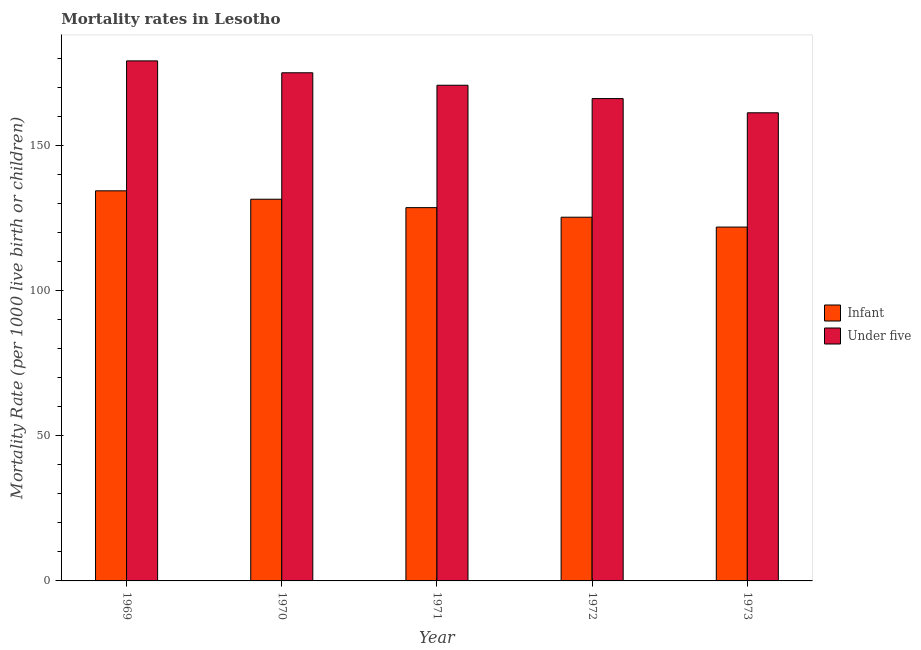Are the number of bars per tick equal to the number of legend labels?
Your answer should be compact. Yes. Are the number of bars on each tick of the X-axis equal?
Offer a terse response. Yes. How many bars are there on the 4th tick from the right?
Keep it short and to the point. 2. In how many cases, is the number of bars for a given year not equal to the number of legend labels?
Provide a short and direct response. 0. What is the infant mortality rate in 1970?
Offer a terse response. 131.6. Across all years, what is the maximum infant mortality rate?
Give a very brief answer. 134.5. Across all years, what is the minimum under-5 mortality rate?
Your response must be concise. 161.4. In which year was the infant mortality rate maximum?
Make the answer very short. 1969. What is the total infant mortality rate in the graph?
Your answer should be very brief. 642.2. What is the difference between the under-5 mortality rate in 1972 and the infant mortality rate in 1973?
Your response must be concise. 4.9. What is the average infant mortality rate per year?
Ensure brevity in your answer.  128.44. In the year 1973, what is the difference between the under-5 mortality rate and infant mortality rate?
Keep it short and to the point. 0. What is the ratio of the under-5 mortality rate in 1969 to that in 1972?
Your answer should be compact. 1.08. Is the under-5 mortality rate in 1971 less than that in 1972?
Your answer should be very brief. No. What is the difference between the highest and the second highest infant mortality rate?
Provide a succinct answer. 2.9. What is the difference between the highest and the lowest infant mortality rate?
Provide a short and direct response. 12.5. In how many years, is the infant mortality rate greater than the average infant mortality rate taken over all years?
Provide a succinct answer. 3. What does the 1st bar from the left in 1972 represents?
Ensure brevity in your answer.  Infant. What does the 2nd bar from the right in 1969 represents?
Offer a terse response. Infant. Are all the bars in the graph horizontal?
Your answer should be compact. No. How many years are there in the graph?
Ensure brevity in your answer.  5. What is the difference between two consecutive major ticks on the Y-axis?
Keep it short and to the point. 50. Does the graph contain grids?
Ensure brevity in your answer.  No. How many legend labels are there?
Make the answer very short. 2. How are the legend labels stacked?
Keep it short and to the point. Vertical. What is the title of the graph?
Offer a very short reply. Mortality rates in Lesotho. What is the label or title of the X-axis?
Offer a terse response. Year. What is the label or title of the Y-axis?
Provide a short and direct response. Mortality Rate (per 1000 live birth or children). What is the Mortality Rate (per 1000 live birth or children) in Infant in 1969?
Your answer should be compact. 134.5. What is the Mortality Rate (per 1000 live birth or children) of Under five in 1969?
Provide a short and direct response. 179.3. What is the Mortality Rate (per 1000 live birth or children) of Infant in 1970?
Provide a succinct answer. 131.6. What is the Mortality Rate (per 1000 live birth or children) of Under five in 1970?
Your answer should be very brief. 175.2. What is the Mortality Rate (per 1000 live birth or children) of Infant in 1971?
Your answer should be compact. 128.7. What is the Mortality Rate (per 1000 live birth or children) of Under five in 1971?
Your answer should be very brief. 170.9. What is the Mortality Rate (per 1000 live birth or children) in Infant in 1972?
Keep it short and to the point. 125.4. What is the Mortality Rate (per 1000 live birth or children) of Under five in 1972?
Make the answer very short. 166.3. What is the Mortality Rate (per 1000 live birth or children) of Infant in 1973?
Give a very brief answer. 122. What is the Mortality Rate (per 1000 live birth or children) of Under five in 1973?
Offer a terse response. 161.4. Across all years, what is the maximum Mortality Rate (per 1000 live birth or children) of Infant?
Your response must be concise. 134.5. Across all years, what is the maximum Mortality Rate (per 1000 live birth or children) of Under five?
Your answer should be compact. 179.3. Across all years, what is the minimum Mortality Rate (per 1000 live birth or children) in Infant?
Ensure brevity in your answer.  122. Across all years, what is the minimum Mortality Rate (per 1000 live birth or children) in Under five?
Your answer should be compact. 161.4. What is the total Mortality Rate (per 1000 live birth or children) in Infant in the graph?
Offer a very short reply. 642.2. What is the total Mortality Rate (per 1000 live birth or children) of Under five in the graph?
Provide a succinct answer. 853.1. What is the difference between the Mortality Rate (per 1000 live birth or children) in Infant in 1969 and that in 1970?
Ensure brevity in your answer.  2.9. What is the difference between the Mortality Rate (per 1000 live birth or children) in Under five in 1969 and that in 1971?
Give a very brief answer. 8.4. What is the difference between the Mortality Rate (per 1000 live birth or children) of Infant in 1969 and that in 1973?
Make the answer very short. 12.5. What is the difference between the Mortality Rate (per 1000 live birth or children) of Infant in 1970 and that in 1971?
Provide a succinct answer. 2.9. What is the difference between the Mortality Rate (per 1000 live birth or children) in Under five in 1970 and that in 1971?
Your answer should be compact. 4.3. What is the difference between the Mortality Rate (per 1000 live birth or children) in Infant in 1970 and that in 1972?
Provide a short and direct response. 6.2. What is the difference between the Mortality Rate (per 1000 live birth or children) in Under five in 1970 and that in 1973?
Keep it short and to the point. 13.8. What is the difference between the Mortality Rate (per 1000 live birth or children) in Infant in 1971 and that in 1972?
Keep it short and to the point. 3.3. What is the difference between the Mortality Rate (per 1000 live birth or children) in Under five in 1971 and that in 1972?
Your response must be concise. 4.6. What is the difference between the Mortality Rate (per 1000 live birth or children) of Infant in 1972 and that in 1973?
Your response must be concise. 3.4. What is the difference between the Mortality Rate (per 1000 live birth or children) in Infant in 1969 and the Mortality Rate (per 1000 live birth or children) in Under five in 1970?
Give a very brief answer. -40.7. What is the difference between the Mortality Rate (per 1000 live birth or children) of Infant in 1969 and the Mortality Rate (per 1000 live birth or children) of Under five in 1971?
Your response must be concise. -36.4. What is the difference between the Mortality Rate (per 1000 live birth or children) of Infant in 1969 and the Mortality Rate (per 1000 live birth or children) of Under five in 1972?
Provide a succinct answer. -31.8. What is the difference between the Mortality Rate (per 1000 live birth or children) of Infant in 1969 and the Mortality Rate (per 1000 live birth or children) of Under five in 1973?
Your answer should be compact. -26.9. What is the difference between the Mortality Rate (per 1000 live birth or children) in Infant in 1970 and the Mortality Rate (per 1000 live birth or children) in Under five in 1971?
Keep it short and to the point. -39.3. What is the difference between the Mortality Rate (per 1000 live birth or children) of Infant in 1970 and the Mortality Rate (per 1000 live birth or children) of Under five in 1972?
Your answer should be very brief. -34.7. What is the difference between the Mortality Rate (per 1000 live birth or children) of Infant in 1970 and the Mortality Rate (per 1000 live birth or children) of Under five in 1973?
Provide a succinct answer. -29.8. What is the difference between the Mortality Rate (per 1000 live birth or children) in Infant in 1971 and the Mortality Rate (per 1000 live birth or children) in Under five in 1972?
Your answer should be compact. -37.6. What is the difference between the Mortality Rate (per 1000 live birth or children) in Infant in 1971 and the Mortality Rate (per 1000 live birth or children) in Under five in 1973?
Offer a very short reply. -32.7. What is the difference between the Mortality Rate (per 1000 live birth or children) of Infant in 1972 and the Mortality Rate (per 1000 live birth or children) of Under five in 1973?
Provide a short and direct response. -36. What is the average Mortality Rate (per 1000 live birth or children) in Infant per year?
Your answer should be very brief. 128.44. What is the average Mortality Rate (per 1000 live birth or children) of Under five per year?
Offer a terse response. 170.62. In the year 1969, what is the difference between the Mortality Rate (per 1000 live birth or children) of Infant and Mortality Rate (per 1000 live birth or children) of Under five?
Provide a succinct answer. -44.8. In the year 1970, what is the difference between the Mortality Rate (per 1000 live birth or children) of Infant and Mortality Rate (per 1000 live birth or children) of Under five?
Your answer should be compact. -43.6. In the year 1971, what is the difference between the Mortality Rate (per 1000 live birth or children) of Infant and Mortality Rate (per 1000 live birth or children) of Under five?
Give a very brief answer. -42.2. In the year 1972, what is the difference between the Mortality Rate (per 1000 live birth or children) in Infant and Mortality Rate (per 1000 live birth or children) in Under five?
Give a very brief answer. -40.9. In the year 1973, what is the difference between the Mortality Rate (per 1000 live birth or children) in Infant and Mortality Rate (per 1000 live birth or children) in Under five?
Give a very brief answer. -39.4. What is the ratio of the Mortality Rate (per 1000 live birth or children) of Infant in 1969 to that in 1970?
Keep it short and to the point. 1.02. What is the ratio of the Mortality Rate (per 1000 live birth or children) in Under five in 1969 to that in 1970?
Provide a short and direct response. 1.02. What is the ratio of the Mortality Rate (per 1000 live birth or children) of Infant in 1969 to that in 1971?
Your answer should be compact. 1.05. What is the ratio of the Mortality Rate (per 1000 live birth or children) in Under five in 1969 to that in 1971?
Your answer should be very brief. 1.05. What is the ratio of the Mortality Rate (per 1000 live birth or children) of Infant in 1969 to that in 1972?
Offer a terse response. 1.07. What is the ratio of the Mortality Rate (per 1000 live birth or children) in Under five in 1969 to that in 1972?
Your response must be concise. 1.08. What is the ratio of the Mortality Rate (per 1000 live birth or children) of Infant in 1969 to that in 1973?
Provide a short and direct response. 1.1. What is the ratio of the Mortality Rate (per 1000 live birth or children) of Under five in 1969 to that in 1973?
Offer a very short reply. 1.11. What is the ratio of the Mortality Rate (per 1000 live birth or children) in Infant in 1970 to that in 1971?
Give a very brief answer. 1.02. What is the ratio of the Mortality Rate (per 1000 live birth or children) in Under five in 1970 to that in 1971?
Your answer should be very brief. 1.03. What is the ratio of the Mortality Rate (per 1000 live birth or children) in Infant in 1970 to that in 1972?
Ensure brevity in your answer.  1.05. What is the ratio of the Mortality Rate (per 1000 live birth or children) of Under five in 1970 to that in 1972?
Your answer should be very brief. 1.05. What is the ratio of the Mortality Rate (per 1000 live birth or children) in Infant in 1970 to that in 1973?
Ensure brevity in your answer.  1.08. What is the ratio of the Mortality Rate (per 1000 live birth or children) of Under five in 1970 to that in 1973?
Provide a short and direct response. 1.09. What is the ratio of the Mortality Rate (per 1000 live birth or children) of Infant in 1971 to that in 1972?
Offer a terse response. 1.03. What is the ratio of the Mortality Rate (per 1000 live birth or children) in Under five in 1971 to that in 1972?
Your answer should be compact. 1.03. What is the ratio of the Mortality Rate (per 1000 live birth or children) of Infant in 1971 to that in 1973?
Make the answer very short. 1.05. What is the ratio of the Mortality Rate (per 1000 live birth or children) in Under five in 1971 to that in 1973?
Your answer should be very brief. 1.06. What is the ratio of the Mortality Rate (per 1000 live birth or children) of Infant in 1972 to that in 1973?
Ensure brevity in your answer.  1.03. What is the ratio of the Mortality Rate (per 1000 live birth or children) of Under five in 1972 to that in 1973?
Provide a short and direct response. 1.03. What is the difference between the highest and the second highest Mortality Rate (per 1000 live birth or children) of Infant?
Offer a very short reply. 2.9. What is the difference between the highest and the lowest Mortality Rate (per 1000 live birth or children) of Infant?
Your response must be concise. 12.5. What is the difference between the highest and the lowest Mortality Rate (per 1000 live birth or children) of Under five?
Your answer should be compact. 17.9. 